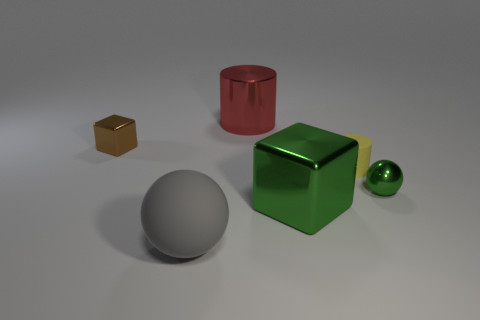Subtract all brown balls. Subtract all red blocks. How many balls are left? 2 Add 2 large green metal blocks. How many objects exist? 8 Subtract all cylinders. How many objects are left? 4 Add 5 tiny cyan matte things. How many tiny cyan matte things exist? 5 Subtract 0 cyan blocks. How many objects are left? 6 Subtract all green spheres. Subtract all gray balls. How many objects are left? 4 Add 3 small brown metal cubes. How many small brown metal cubes are left? 4 